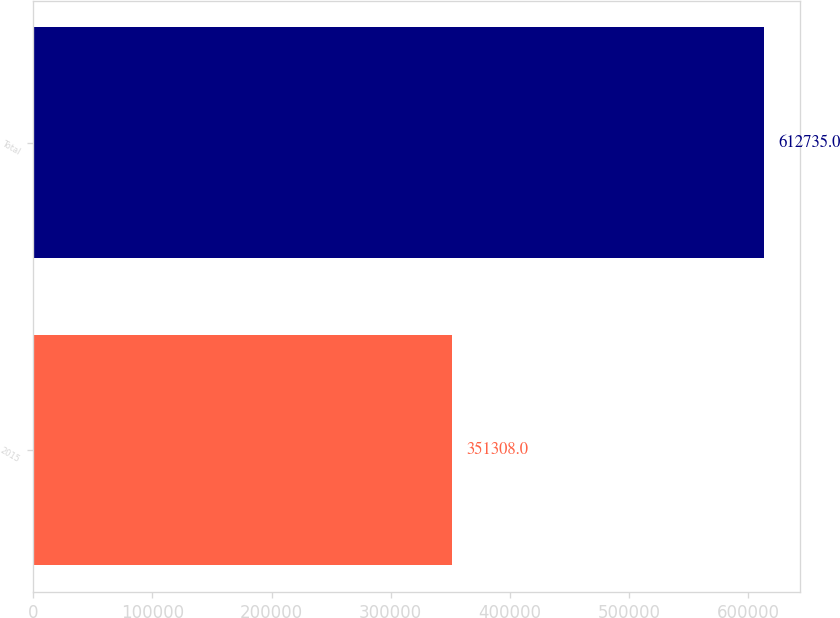Convert chart to OTSL. <chart><loc_0><loc_0><loc_500><loc_500><bar_chart><fcel>2015<fcel>Total<nl><fcel>351308<fcel>612735<nl></chart> 